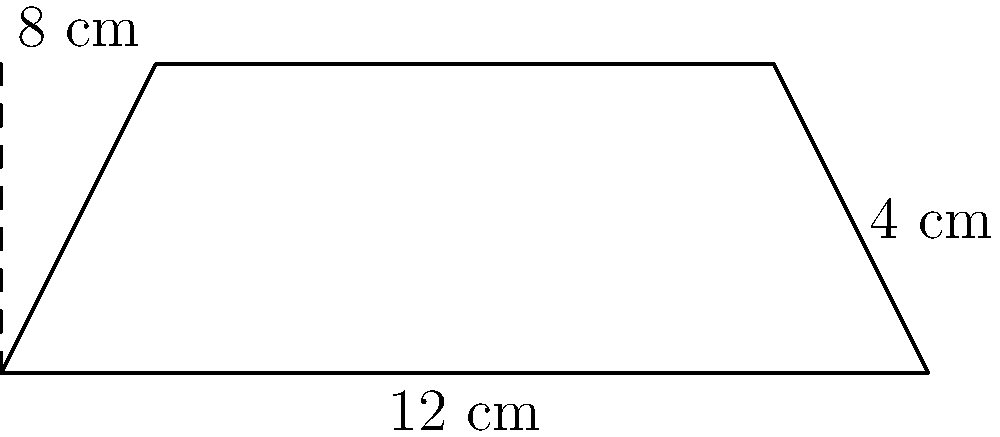As a photography expert, you're designing a new darkroom developing tray. The tray has a trapezoid shape with parallel sides of 8 cm and 12 cm, and a height of 4 cm. Calculate the area of the tray's base in square centimeters. To calculate the area of a trapezoid, we use the formula:

$$A = \frac{1}{2}(b_1 + b_2)h$$

Where:
$A$ = area
$b_1$ and $b_2$ = lengths of the parallel sides
$h$ = height (perpendicular distance between the parallel sides)

Given:
$b_1 = 8$ cm
$b_2 = 12$ cm
$h = 4$ cm

Substituting these values into the formula:

$$A = \frac{1}{2}(8 + 12) \times 4$$

$$A = \frac{1}{2}(20) \times 4$$

$$A = 10 \times 4$$

$$A = 40$$

Therefore, the area of the darkroom developing tray's base is 40 square centimeters.
Answer: 40 cm² 